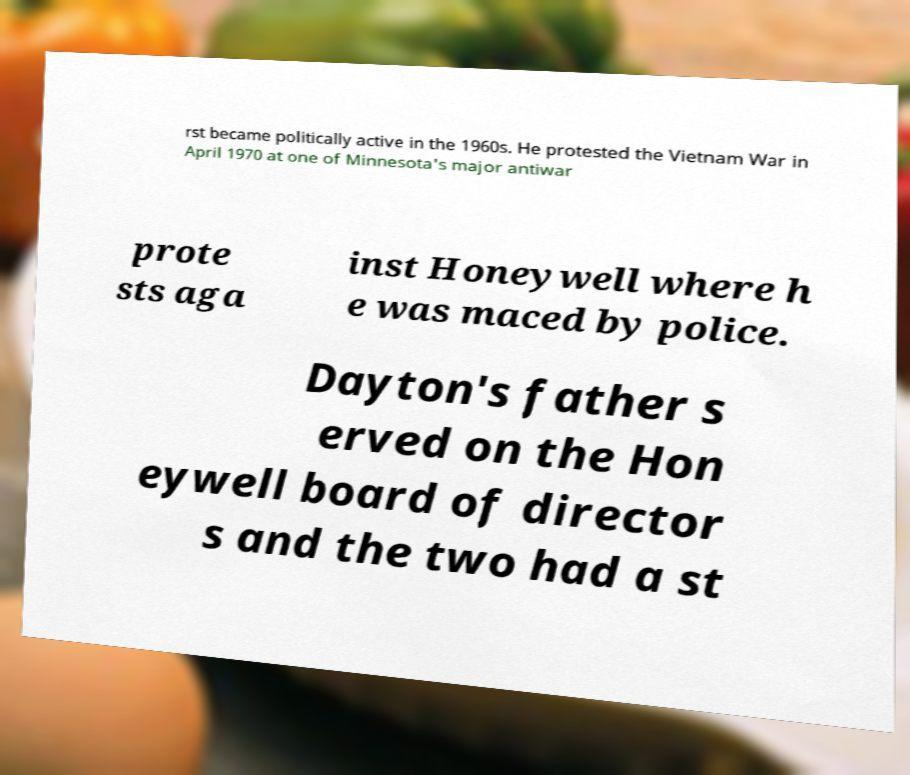There's text embedded in this image that I need extracted. Can you transcribe it verbatim? rst became politically active in the 1960s. He protested the Vietnam War in April 1970 at one of Minnesota's major antiwar prote sts aga inst Honeywell where h e was maced by police. Dayton's father s erved on the Hon eywell board of director s and the two had a st 